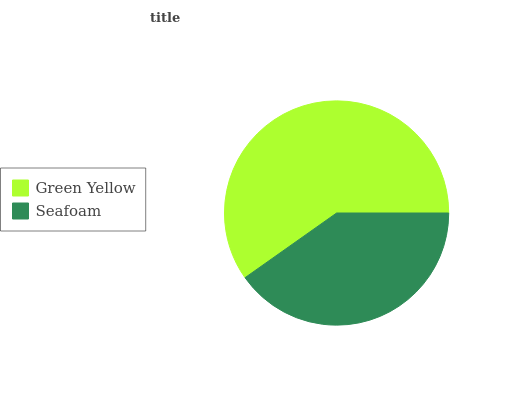Is Seafoam the minimum?
Answer yes or no. Yes. Is Green Yellow the maximum?
Answer yes or no. Yes. Is Seafoam the maximum?
Answer yes or no. No. Is Green Yellow greater than Seafoam?
Answer yes or no. Yes. Is Seafoam less than Green Yellow?
Answer yes or no. Yes. Is Seafoam greater than Green Yellow?
Answer yes or no. No. Is Green Yellow less than Seafoam?
Answer yes or no. No. Is Green Yellow the high median?
Answer yes or no. Yes. Is Seafoam the low median?
Answer yes or no. Yes. Is Seafoam the high median?
Answer yes or no. No. Is Green Yellow the low median?
Answer yes or no. No. 